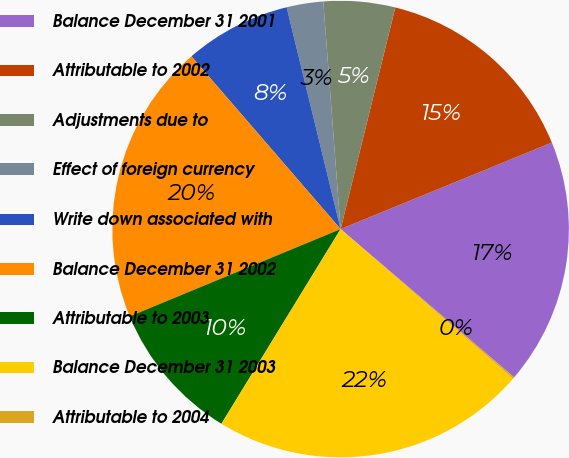Convert chart. <chart><loc_0><loc_0><loc_500><loc_500><pie_chart><fcel>Balance December 31 2001<fcel>Attributable to 2002<fcel>Adjustments due to<fcel>Effect of foreign currency<fcel>Write down associated with<fcel>Balance December 31 2002<fcel>Attributable to 2003<fcel>Balance December 31 2003<fcel>Attributable to 2004<nl><fcel>17.44%<fcel>14.96%<fcel>5.06%<fcel>2.59%<fcel>7.54%<fcel>19.91%<fcel>10.01%<fcel>22.38%<fcel>0.11%<nl></chart> 